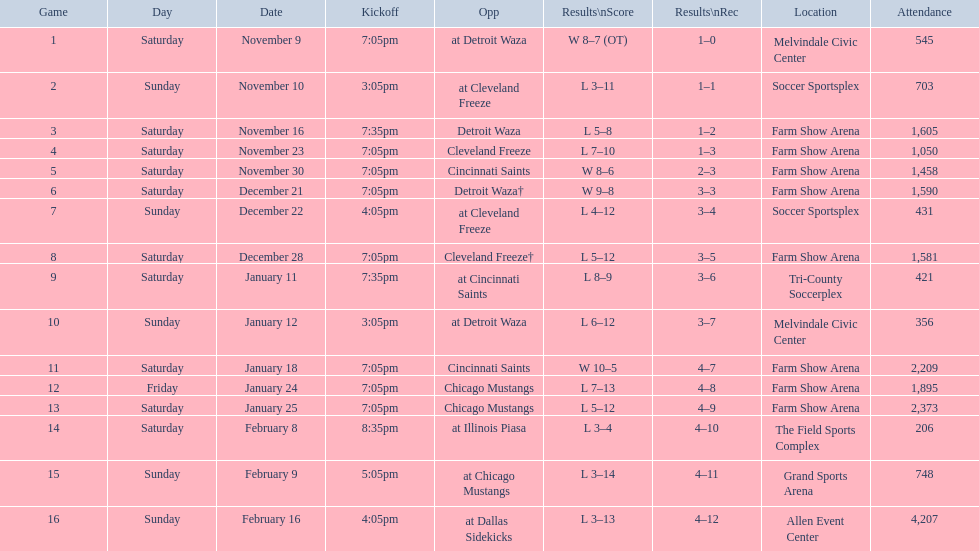How long was the teams longest losing streak? 5 games. 